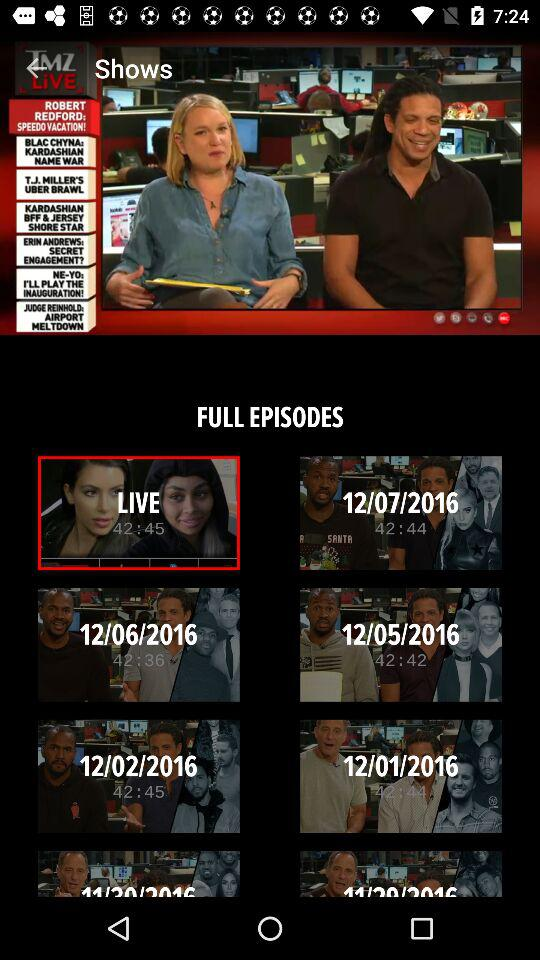What episode has a duration of 42.36? The episode is 12/06/2016. 